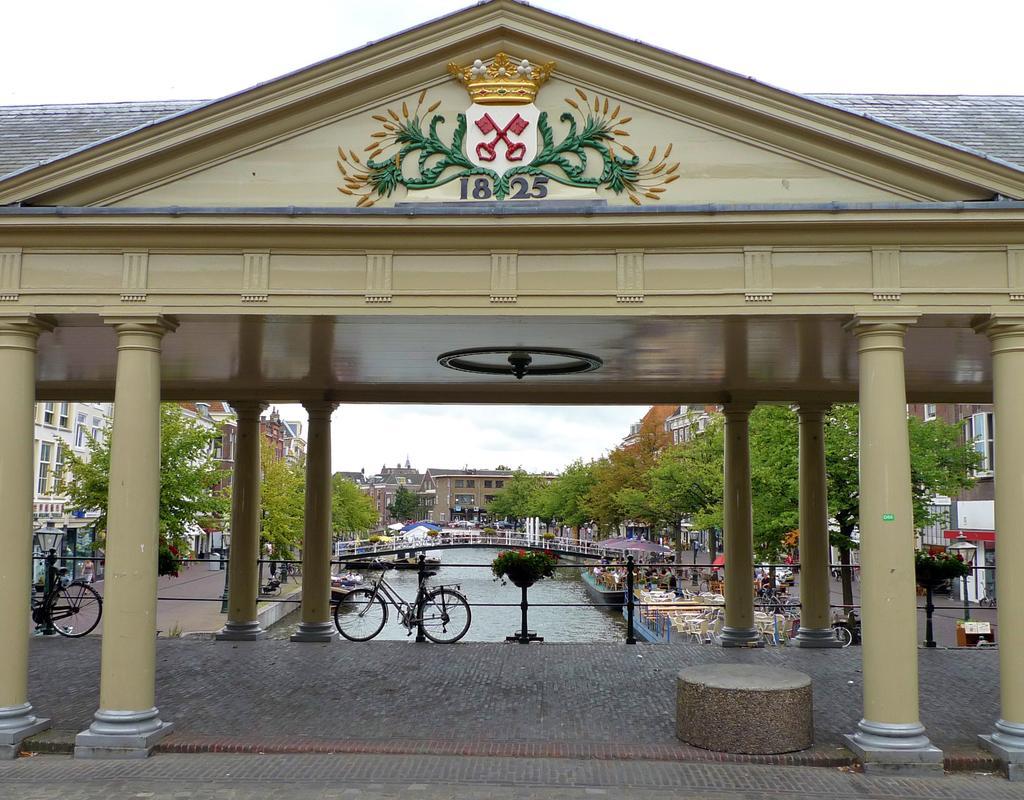In one or two sentences, can you explain what this image depicts? In this image at front there is arch. At center of the image there is lake and we can see bridge. On both right and left side of the image there are trees. At the background there are buildings and we can see cycles and at the top there is sky. 